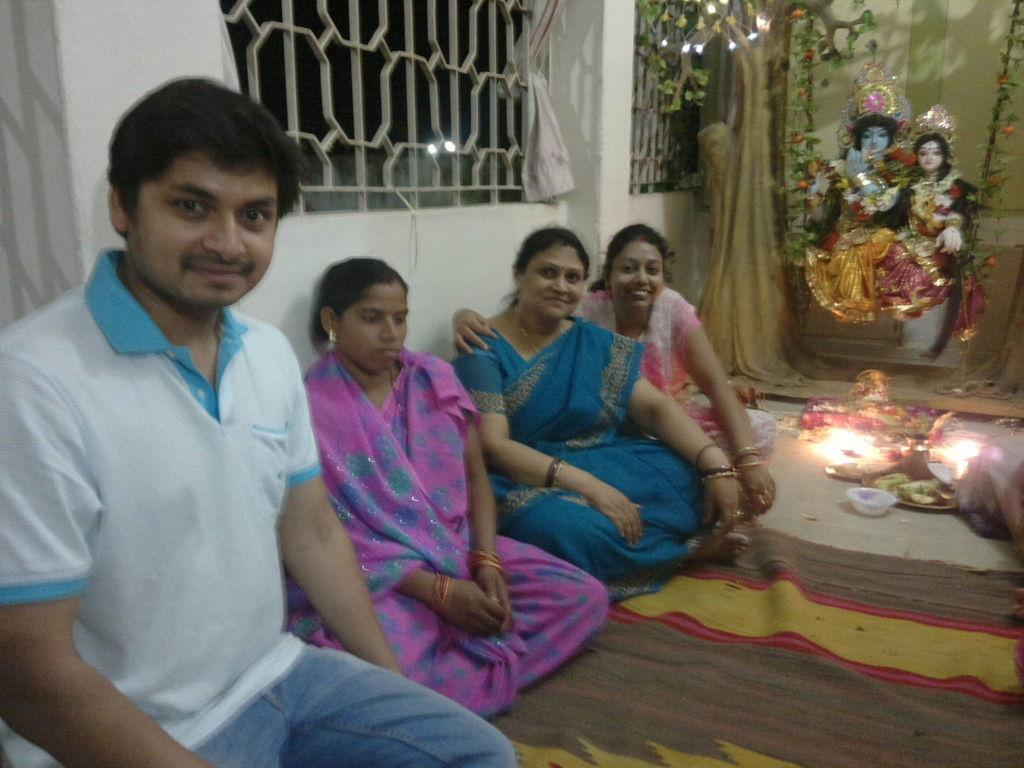How many people are in the image? There are four persons in the middle of the image. What can be seen on the right side of the image? There is a light on the right side of the image. What is located at the top of the image? There are statues at the top of the image. What is on the left side of the image? There is an iron grill on the left side of the image. What type of coal is being used to heat the tub in the image? There is no tub or coal present in the image. How many passengers are visible in the image? There is no reference to passengers in the image; it features four persons. 